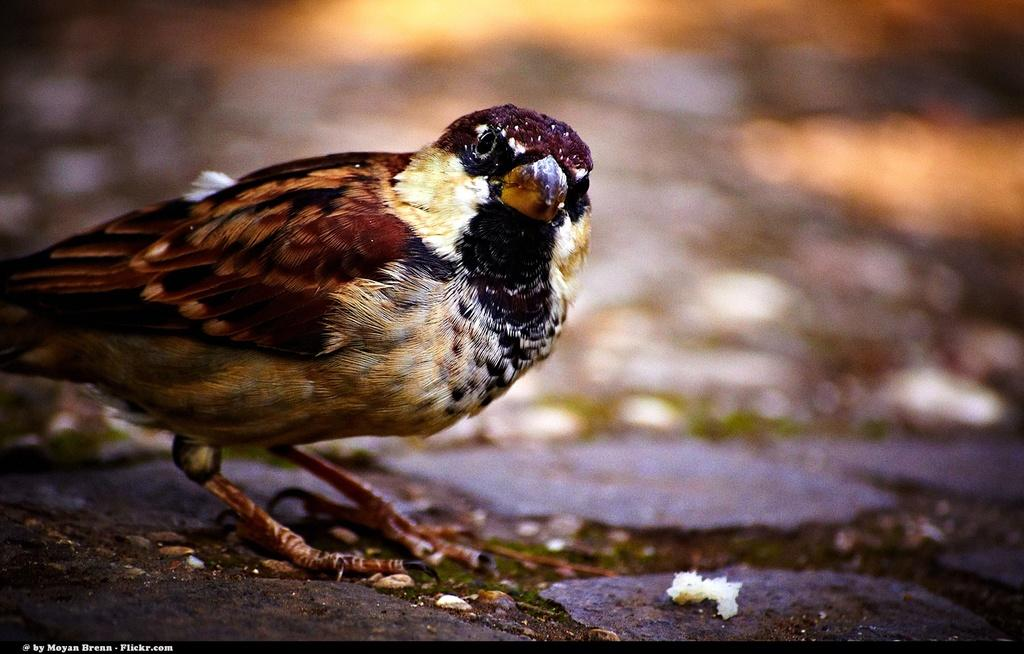What is the main subject in the foreground of the image? There is a bird in the foreground of the image. What can be seen on the ground near the bird? There is a white substance on the ground in the foreground. What is the condition of the background in the image? The background of the image is blurred. How many bikes are parked near the bird in the image? There are no bikes present in the image; it features a bird and a white substance on the ground. What type of teeth can be seen on the bird in the image? Birds do not have teeth, so there are no teeth visible on the bird in the image. 